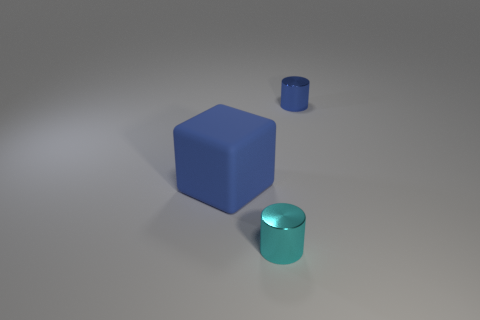Are there more blue objects on the left side of the blue cylinder than blue matte spheres?
Keep it short and to the point. Yes. Are there any other things that have the same material as the large blue thing?
Keep it short and to the point. No. The shiny object that is the same color as the matte block is what shape?
Give a very brief answer. Cylinder. How many blocks are either shiny things or small blue matte things?
Provide a short and direct response. 0. The tiny shiny cylinder that is to the left of the tiny cylinder that is behind the tiny cyan cylinder is what color?
Your answer should be compact. Cyan. There is a rubber block; is its color the same as the small shiny cylinder behind the blue block?
Offer a terse response. Yes. There is a blue cylinder that is the same material as the cyan cylinder; what size is it?
Your response must be concise. Small. Is there a tiny object in front of the large blue object to the left of the blue object that is behind the big rubber block?
Your response must be concise. Yes. How many shiny cylinders have the same size as the cyan metallic thing?
Provide a succinct answer. 1. Do the metal cylinder that is behind the large blue rubber cube and the object left of the tiny cyan thing have the same size?
Your answer should be very brief. No. 